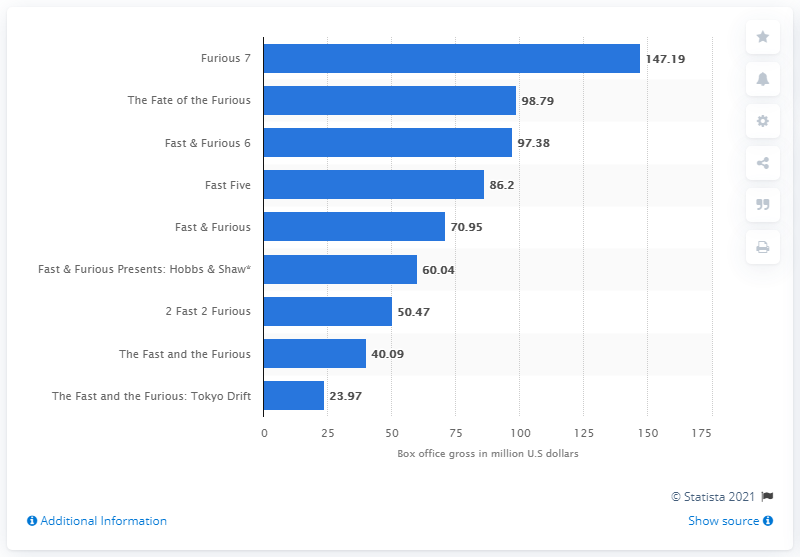List a handful of essential elements in this visual. How much did Fast & Furious 6 gross? It grossed $147.19 million. The movie 'Furious 7' generated $147.19 million on the first weekend of its release. The action film 'Furious 7' generated a significant amount of revenue on its first weekend of release, earning $147.19 million. 